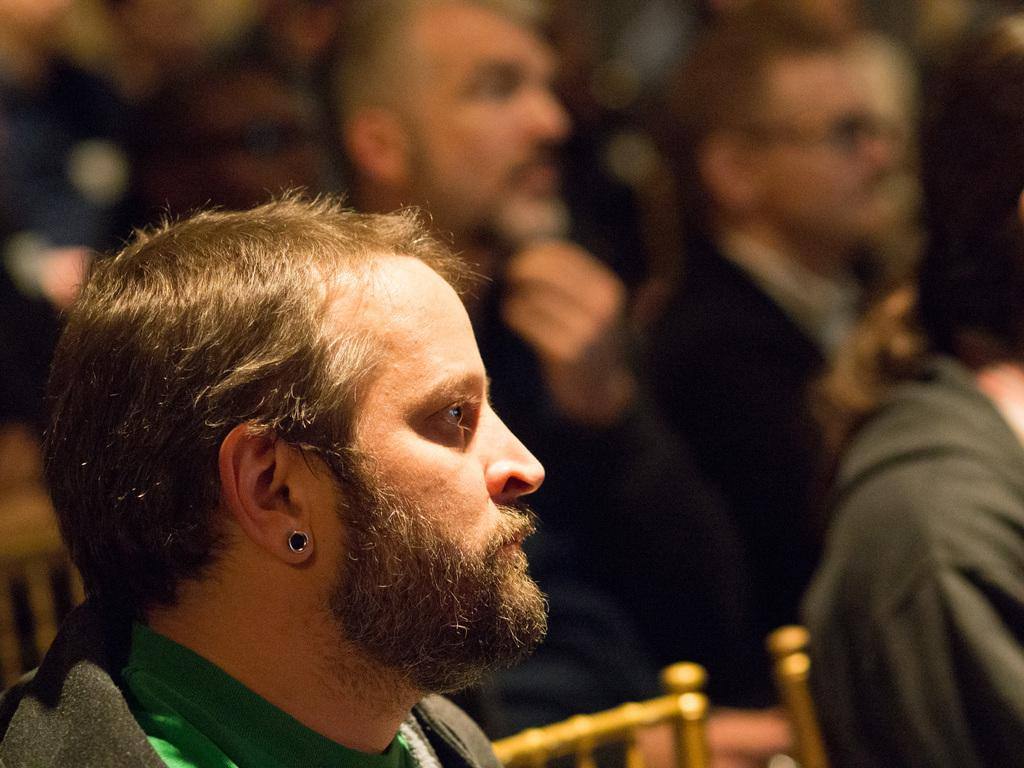How many people are in the image? There is a group of people in the image, but the exact number is not specified. What are the people doing in the image? The people are sitting on chairs in the image. What type of sticks can be seen hanging from the curtain in the image? There is no mention of sticks or curtains in the image; it only features a group of people sitting on chairs. 